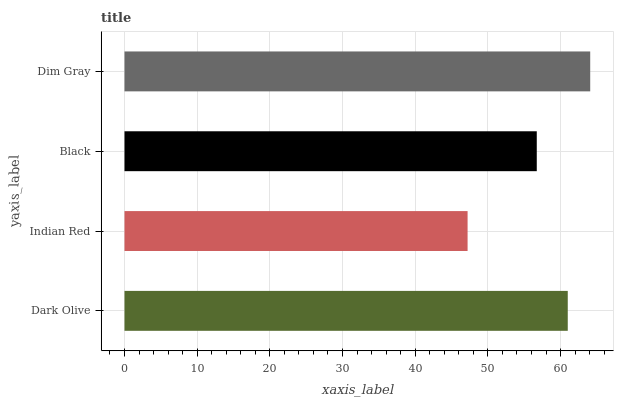Is Indian Red the minimum?
Answer yes or no. Yes. Is Dim Gray the maximum?
Answer yes or no. Yes. Is Black the minimum?
Answer yes or no. No. Is Black the maximum?
Answer yes or no. No. Is Black greater than Indian Red?
Answer yes or no. Yes. Is Indian Red less than Black?
Answer yes or no. Yes. Is Indian Red greater than Black?
Answer yes or no. No. Is Black less than Indian Red?
Answer yes or no. No. Is Dark Olive the high median?
Answer yes or no. Yes. Is Black the low median?
Answer yes or no. Yes. Is Black the high median?
Answer yes or no. No. Is Dim Gray the low median?
Answer yes or no. No. 